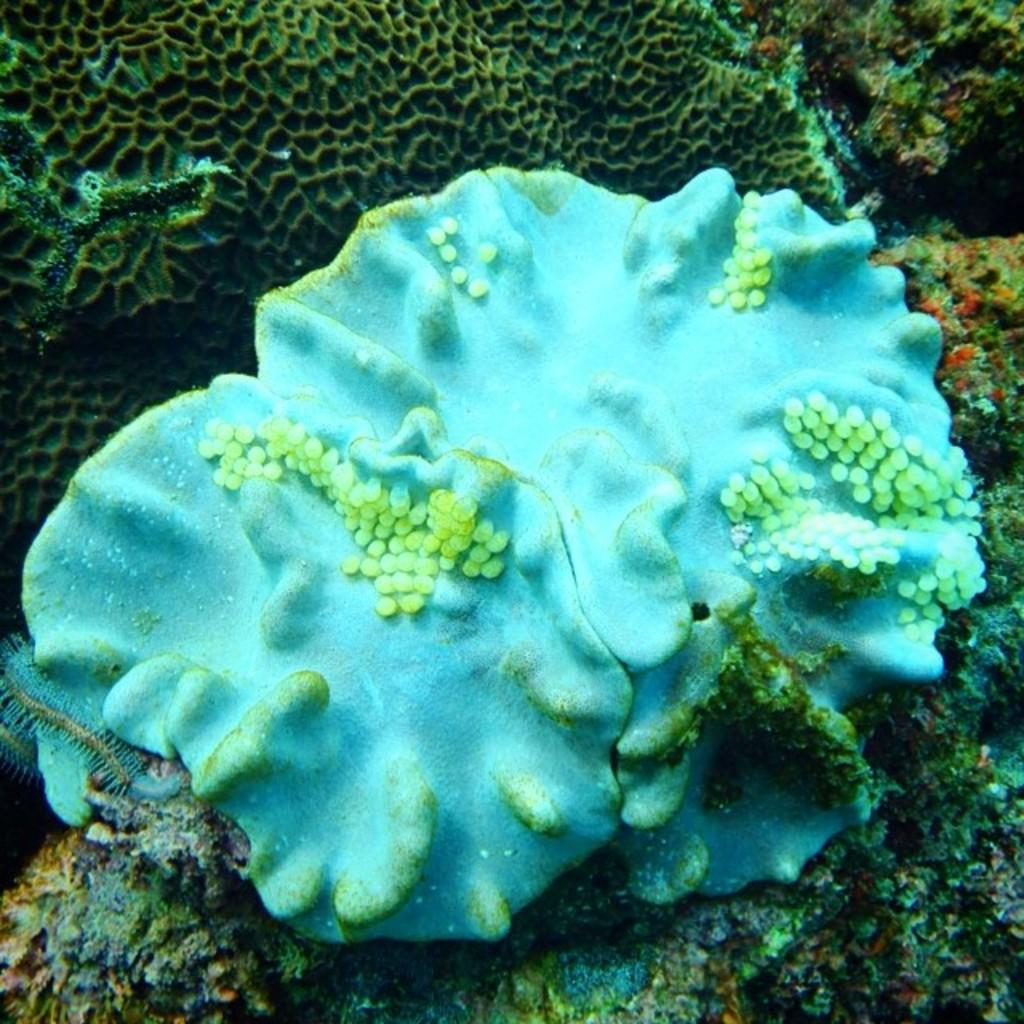What type of plants can be seen in the image? There are underwater plants in the image. What time of day is it in the image? The time of day cannot be determined from the image, as it only shows underwater plants. What part of a rifle can be seen in the image? There is no rifle present in the image; it only features underwater plants. 